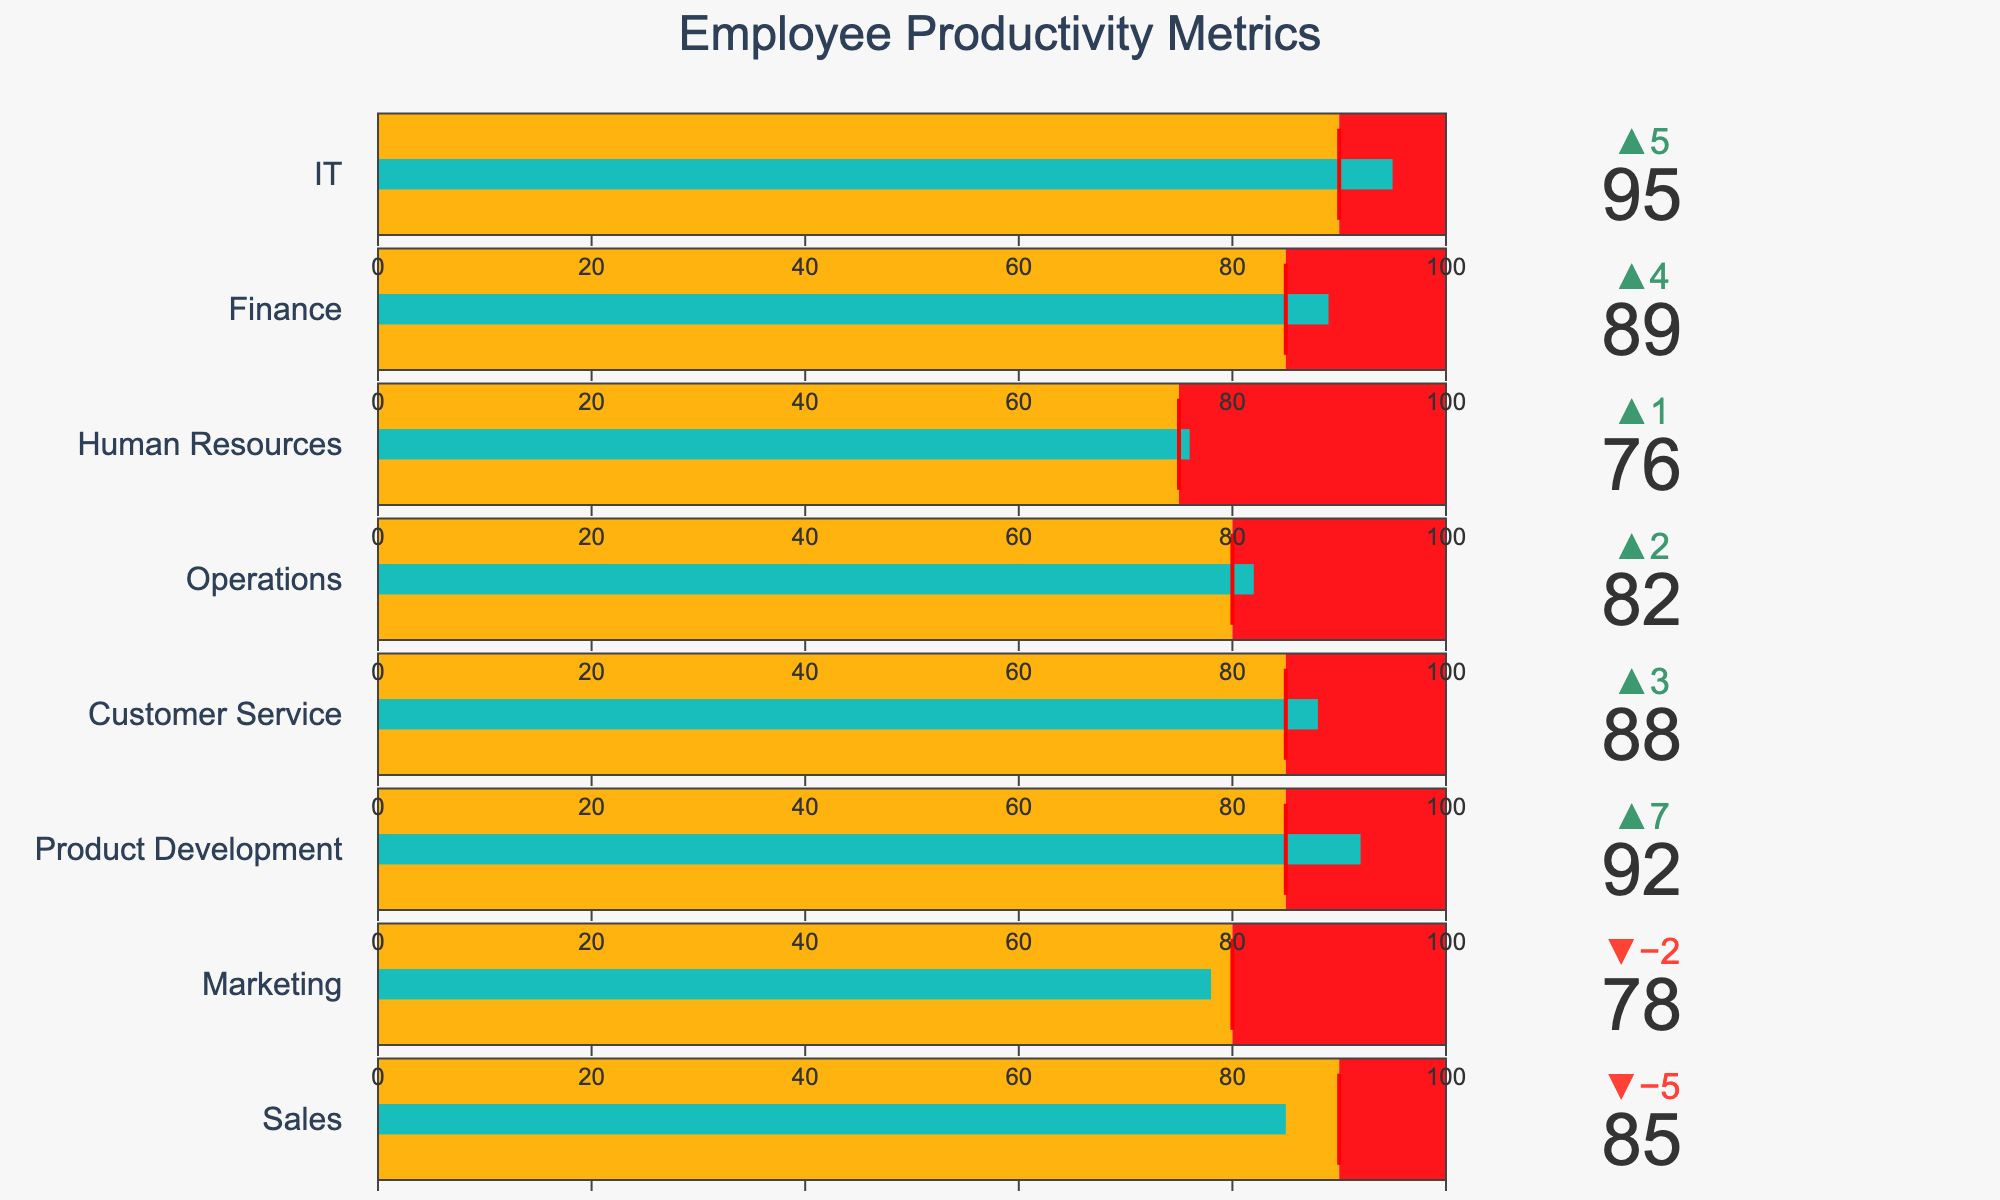What is the title of the figure? The title is usually displayed at the top of the figure and provides a brief description of what the figure represents.
Answer: Employee Productivity Metrics Which department has the highest actual productivity? Compare the actual productivity values of all departments and find the highest one. IT shows the highest with 95.
Answer: IT How much did the Sales department miss its target productivity by? Subtract the Sales department's actual productivity from its target productivity: 90 - 85 = 5.
Answer: 5 Which departments exceeded their target productivity? Identify departments where the actual productivity is greater than the target productivity. These are Product Development (92 > 85), Customer Service (88 > 85), Operations (82 > 80), Finance (89 > 85), and IT (95 > 90).
Answer: Product Development, Customer Service, Operations, Finance, IT How does the Marketing department's actual productivity compare to its target productivity? Check the actual and target productivity values for Marketing: Marketing has 78 actual productivity and 80 target, so it is below the target.
Answer: Below What is the average target productivity across all departments? Sum the target productivity values of all departments and divide by the number of departments: (90 + 80 + 85 + 85 + 80 + 75 + 85 + 90) / 8 = 84.
Answer: 84 What is the range of productivity for the Human Resources department? The range is the difference between the maximum and minimum values: 100 - 76 = 24.
Answer: 24 Which department has the smallest difference between actual productivity and target productivity? Calculate the difference for all departments and find the smallest: Differences are Sales (5), Marketing (2), Product Development (7), Customer Service (3), Operations (2), Human Resources (1), Finance (4), IT (5). The smallest is Human Resources with 1.
Answer: Human Resources What color represents the steps that are below the target productivity threshold? The steps below the target productivity threshold are colored in yellow.
Answer: Yellow 